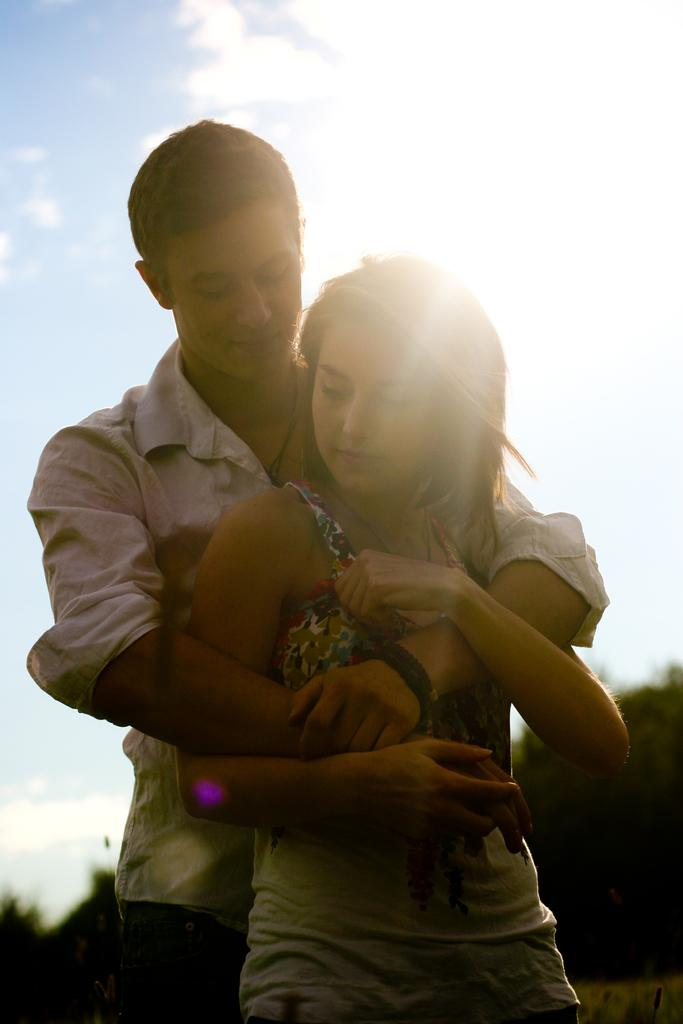Who are the people in the image? There is a man and a woman in the image. What is the man doing to the woman? The man is hugging the woman. What can be seen in the background of the image? There are trees in the background of the image. What is visible in the sky in the image? There are clouds visible in the sky. What type of lamp is hanging from the tree in the image? There is no lamp present in the image; it features a man hugging a woman with trees and clouds visible in the background. 